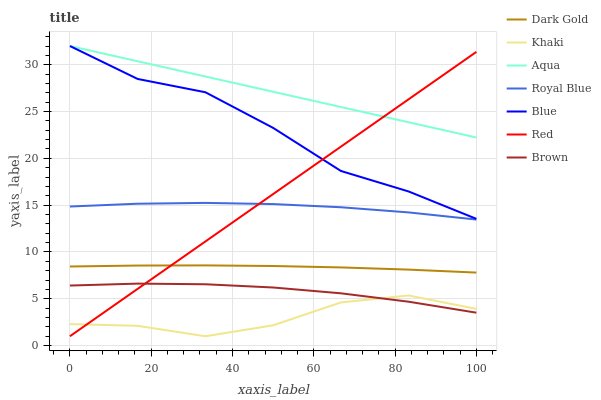Does Khaki have the minimum area under the curve?
Answer yes or no. Yes. Does Aqua have the maximum area under the curve?
Answer yes or no. Yes. Does Brown have the minimum area under the curve?
Answer yes or no. No. Does Brown have the maximum area under the curve?
Answer yes or no. No. Is Red the smoothest?
Answer yes or no. Yes. Is Blue the roughest?
Answer yes or no. Yes. Is Brown the smoothest?
Answer yes or no. No. Is Brown the roughest?
Answer yes or no. No. Does Khaki have the lowest value?
Answer yes or no. Yes. Does Brown have the lowest value?
Answer yes or no. No. Does Aqua have the highest value?
Answer yes or no. Yes. Does Brown have the highest value?
Answer yes or no. No. Is Khaki less than Dark Gold?
Answer yes or no. Yes. Is Aqua greater than Brown?
Answer yes or no. Yes. Does Red intersect Dark Gold?
Answer yes or no. Yes. Is Red less than Dark Gold?
Answer yes or no. No. Is Red greater than Dark Gold?
Answer yes or no. No. Does Khaki intersect Dark Gold?
Answer yes or no. No. 